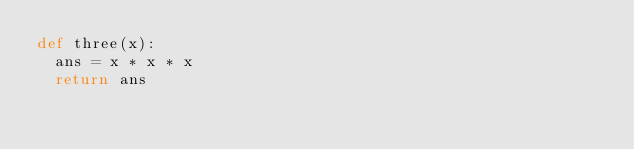Convert code to text. <code><loc_0><loc_0><loc_500><loc_500><_Python_>def three(x):
  ans = x * x * x
  return ans</code> 